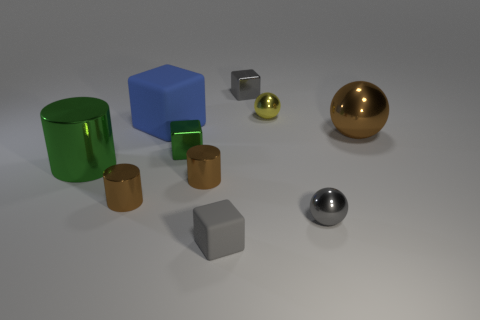Subtract all large cubes. How many cubes are left? 3 Subtract all brown balls. How many balls are left? 2 Subtract 3 cylinders. How many cylinders are left? 0 Subtract all blocks. How many objects are left? 6 Subtract all red spheres. How many green blocks are left? 1 Add 9 large cylinders. How many large cylinders are left? 10 Add 2 shiny spheres. How many shiny spheres exist? 5 Subtract 0 brown blocks. How many objects are left? 10 Subtract all blue cylinders. Subtract all yellow spheres. How many cylinders are left? 3 Subtract all green objects. Subtract all small yellow rubber blocks. How many objects are left? 8 